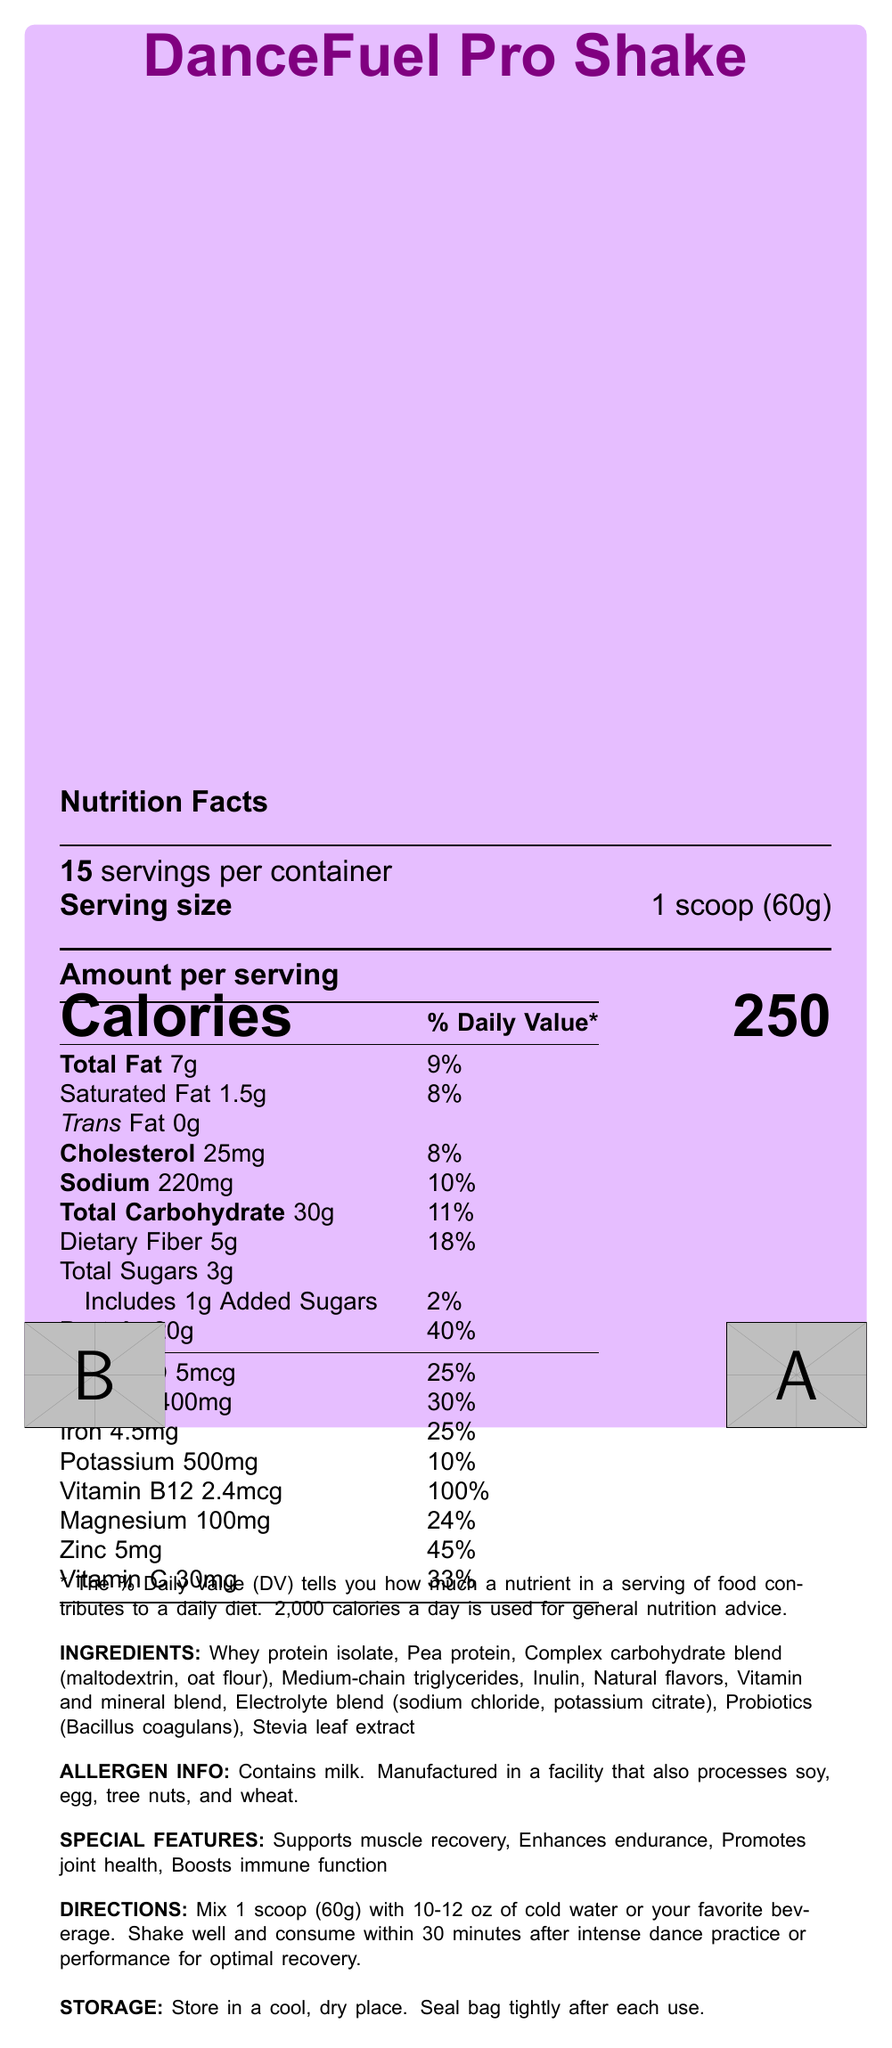What is the serving size of DanceFuel Pro Shake? The document specifies that the serving size is 1 scoop, which weighs 60 grams.
Answer: 1 scoop (60g) How many servings are there per container? The document states that there are 15 servings per container.
Answer: 15 What are the total calories per serving? The document lists the amount of calories per serving as 250.
Answer: 250 What is the amount of protein per serving? According to the document, each serving contains 20 grams of protein.
Answer: 20g What are the directions for consuming DanceFuel Pro Shake? The document provides specific directions under the "DIRECTIONS" section.
Answer: Mix 1 scoop (60g) with 10-12 oz of cold water or your favorite beverage. Shake well and consume within 30 minutes after intense dance practice or performance for optimal recovery. Which of the following special features is NOT mentioned in the document? A. Supports muscle recovery B. Enhances endurance C. Promotes weight loss D. Boosts immune function The document mentions "Supports muscle recovery," "Enhances endurance," "Promotes joint health," and "Boosts immune function," but it does not mention "Promotes weight loss."
Answer: C. Promotes weight loss What is the percentage of daily value for calcium per serving? A. 10% B. 30% C. 45% D. 25% The document indicates that the daily value percentage for calcium per serving is 30%.
Answer: B. 30% Is the product NSF Certified for Sport? The certifications section of the document lists "NSF Certified for Sport."
Answer: Yes Summarize the main idea of the document. The document provides a comprehensive overview of the DanceFuel Pro Shake, including its nutritional facts, ingredients, special features, directions for use, allergen information, and certifications.
Answer: The DanceFuel Pro Shake is a balanced meal replacement shake designed for dancers. It includes essential nutrients to support endurance and recovery, with noteworthy features such as muscle recovery support, enhancement of endurance, joint health promotion, and immune function boosting. The product is also NSF Certified for Sport and Non-GMO Project Verified. It contains a variety of proteins, complex carbohydrates, electrolytes, and probiotics. What is the amount of saturated fat per serving? The document states that each serving contains 1.5 grams of saturated fat.
Answer: 1.5g Can you name all the ingredients in the DanceFuel Pro Shake? The document lists all the ingredients in the "INGREDIENTS" section.
Answer: Whey protein isolate, Pea protein, Complex carbohydrate blend (maltodextrin, oat flour), Medium-chain triglycerides, Inulin, Natural flavors, Vitamin and mineral blend, Electrolyte blend (sodium chloride, potassium citrate), Probiotics (Bacillus coagulans), Stevia leaf extract How many grams of dietary fiber are in one serving? The document informs that there are 5 grams of dietary fiber in each serving.
Answer: 5g What is the source of sweetening in the DanceFuel Pro Shake? The document lists Stevia leaf extract as one of the ingredients, which is a natural sweetener.
Answer: Stevia leaf extract What is the total fat content per serving and its daily value percentage? The total fat content per serving is 7 grams, which represents 9% of the daily value.
Answer: 7g, 9% Does the DanceFuel Pro Shake contain any trans fat? The document specifies that the trans fat content is 0 grams per serving.
Answer: No How should the product be stored? The storage instructions are given under the "STORAGE" section of the document.
Answer: Store in a cool, dry place. Seal bag tightly after each use. What is the primary benefit mentioned for consuming the DanceFuel Pro Shake after intense dance practice? The directions mention that consuming the shake within 30 minutes after intense dance practice or performance is for optimal recovery.
Answer: Optimal recovery How many milligrams of potassium are in one serving? The document shows that one serving contains 500 milligrams of potassium.
Answer: 500mg Is the product suitable for individuals with tree nut allergies, based on the allergen information? While the document indicates that the product contains milk and is manufactured in a facility that processes soy, egg, tree nuts, and wheat, it does not explicitly state whether it is safe for individuals with tree nut allergies.
Answer: Not enough information 